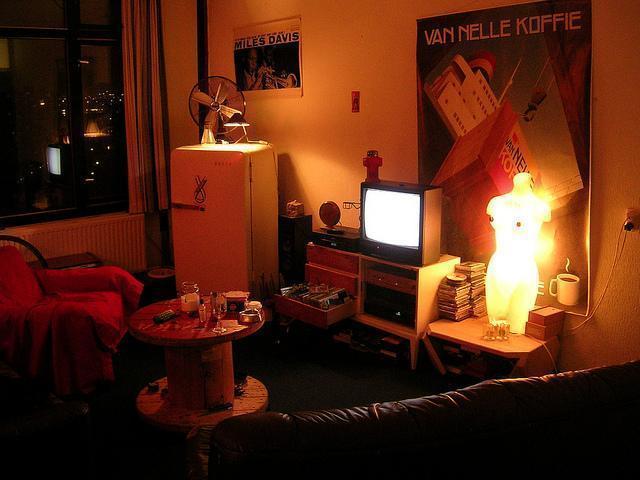The last word on the poster on the right is most likely pronounced similarly to what?
Make your selection from the four choices given to correctly answer the question.
Options: Coffee, juice, seltzer, soda. Coffee. 